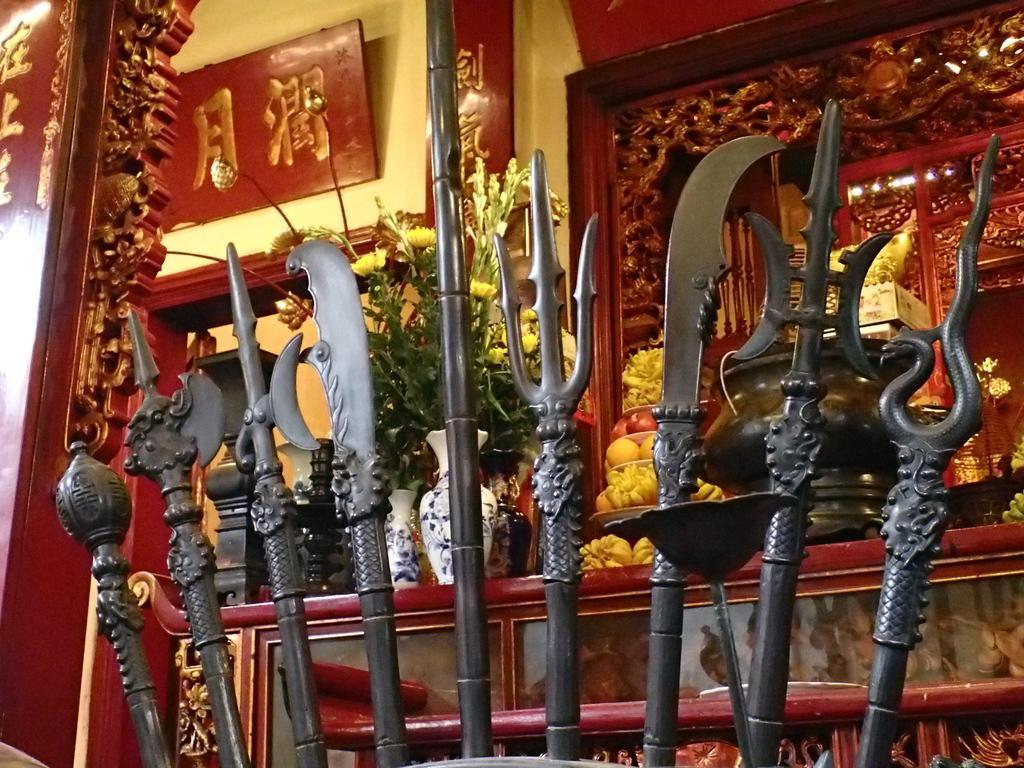Could you give a brief overview of what you see in this image? In the image there are big swords,knives in the front and behind there is shelf with flower vase,fruits and vessels on it, and behind it there is a wall with some scriptures above it and below there is an entrance. 